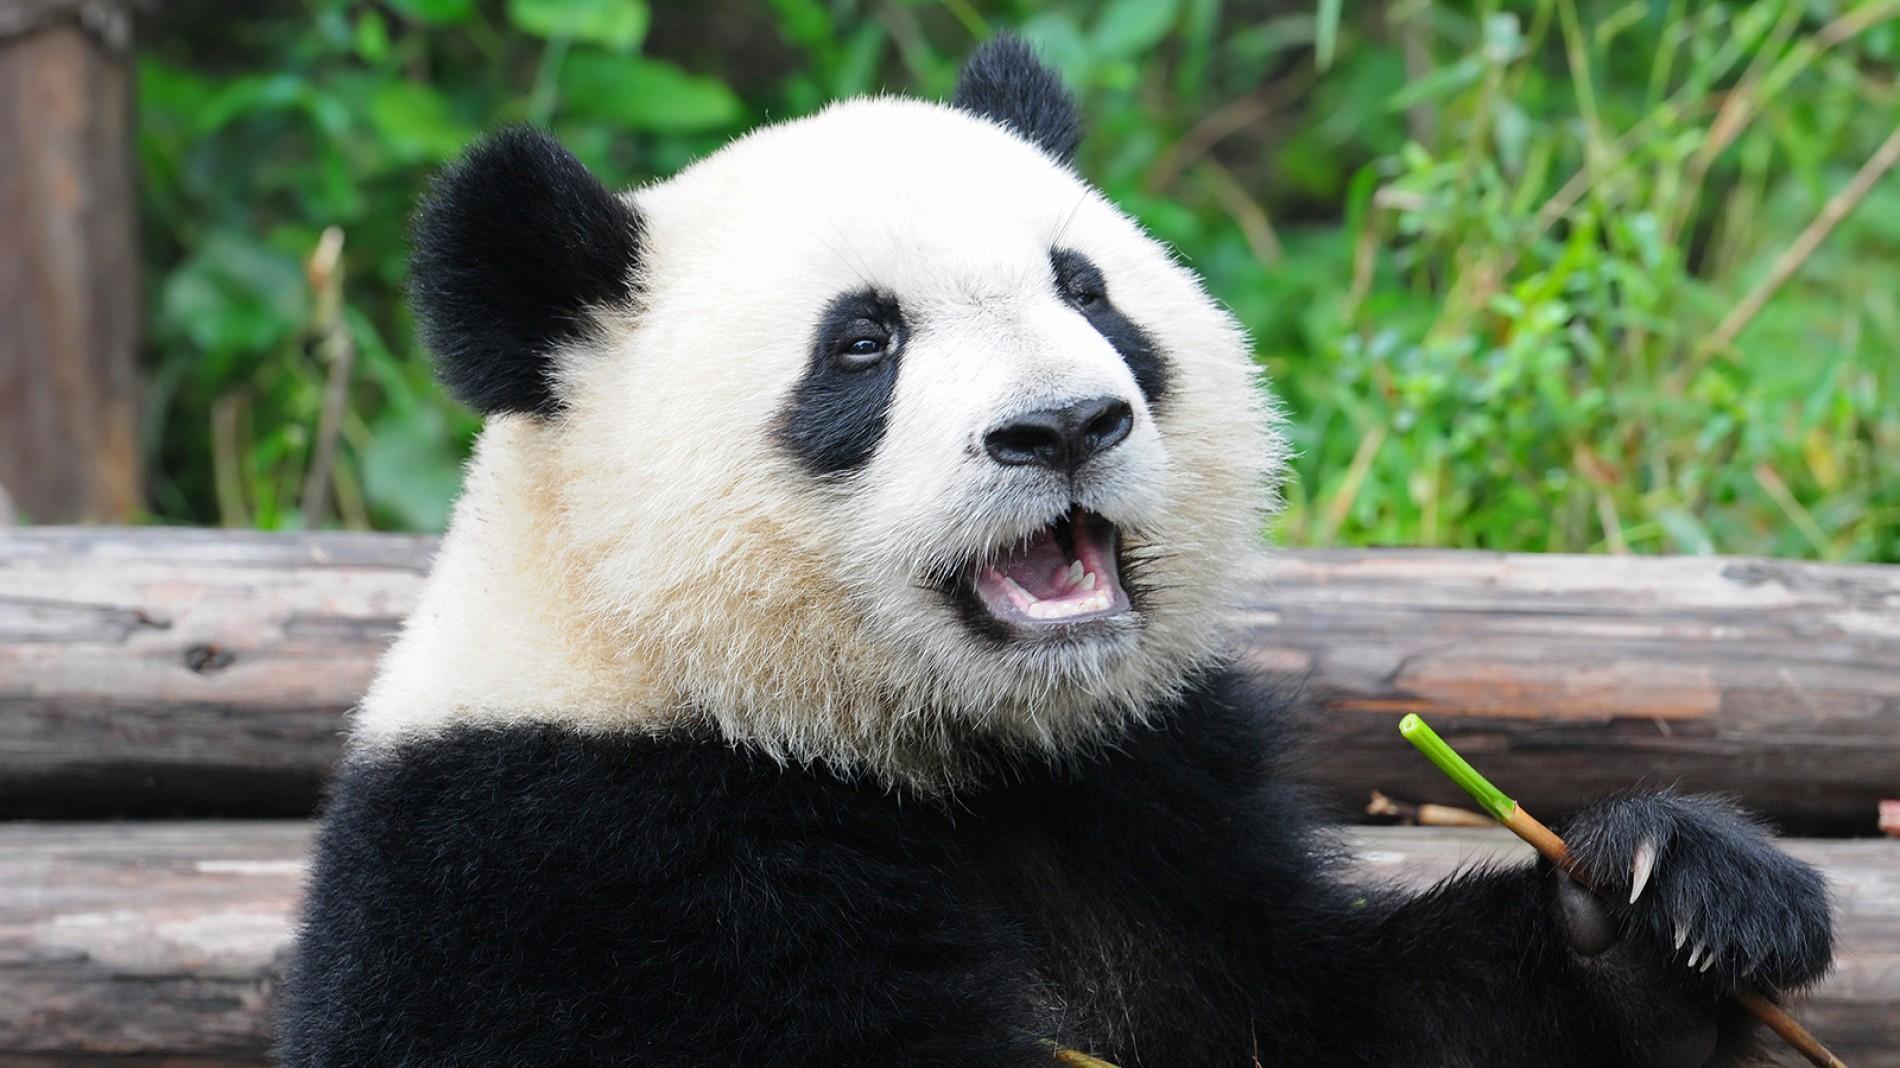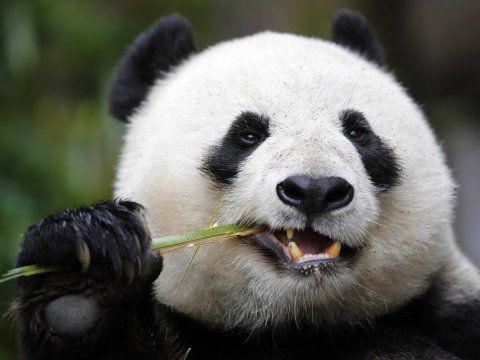The first image is the image on the left, the second image is the image on the right. For the images displayed, is the sentence "In one of the images there are two pandas huddled together." factually correct? Answer yes or no. No. 